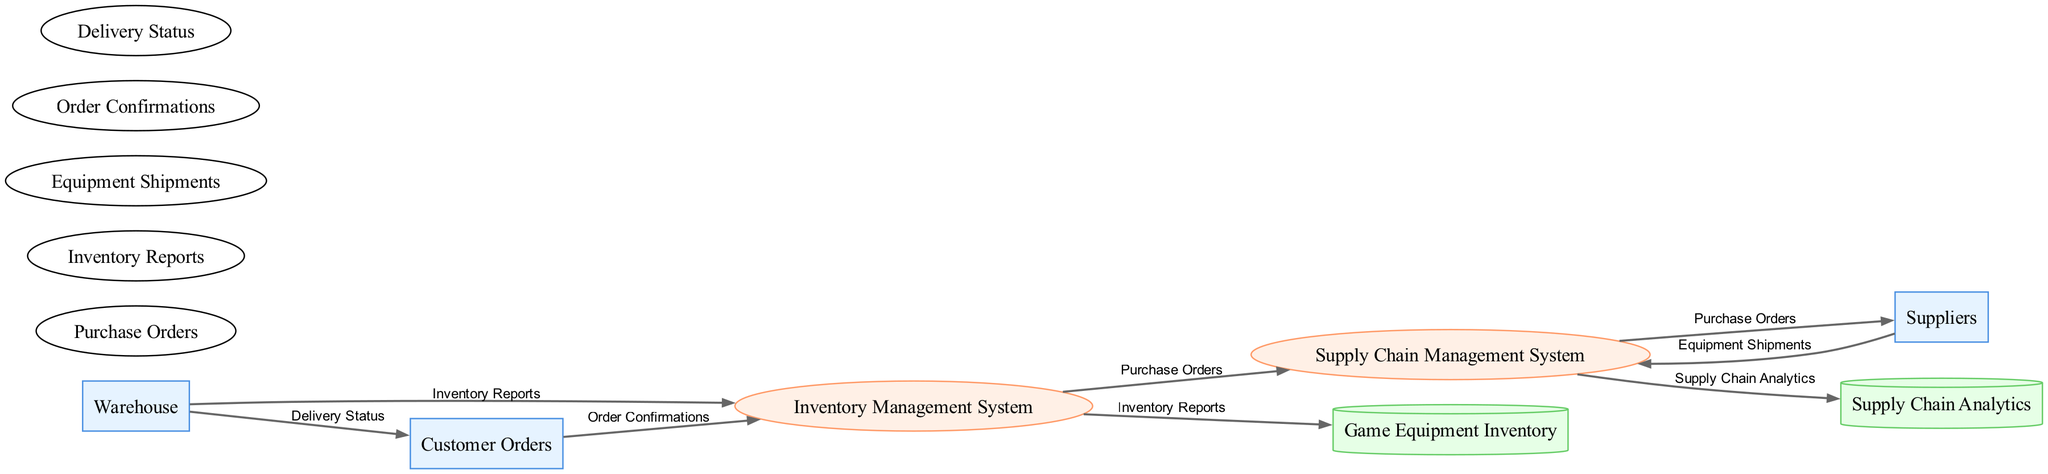What is the number of external entities in the diagram? The diagram includes three external entities: Warehouse, Suppliers, and Customer Orders. By counting these, we see there are a total of three external entities.
Answer: 3 What type of relationship exists between Suppliers and the Supply Chain Management System? The relationship between Suppliers and the Supply Chain Management System is a data flow, specifically named Equipment Shipments. This indicates that data moves from Suppliers to the Supply Chain Management System.
Answer: Data flow What data flow originates from Warehouse? The data flow that originates from Warehouse is titled Inventory Reports, which indicates that the Warehouse sends this information to the Inventory Management System.
Answer: Inventory Reports Which process receives Order Confirmations? The Inventory Management System receives Order Confirmations. This flow shows how customer orders are communicated to the inventory system for processing.
Answer: Inventory Management System How many data flows are depicted in the diagram? There are six distinct data flows represented in the diagram: Inventory Reports, Equipment Shipments, Purchase Orders, Order Confirmations, Delivery Status, and Supply Chain Analytics. Counting these gives six data flows in total.
Answer: 6 What is the purpose of the Supply Chain Analytics data store? The Supply Chain Analytics data store collects information from the Supply Chain Management System for analytical purposes, allowing for insights and improvements in the supply chain operations.
Answer: Analytics Which entity does the Inventory Management System communicate with for Purchase Orders? The Inventory Management System communicates with both the Supply Chain Management System and Suppliers to handle Purchase Orders, indicating a dual relationship for procurement processes.
Answer: Suppliers and Supply Chain Management System What is the final destination of the Delivery Status flow? The Delivery Status flow has its final destination as Customer Orders, indicating that the status of deliveries is communicated back to the customers through orders.
Answer: Customer Orders 